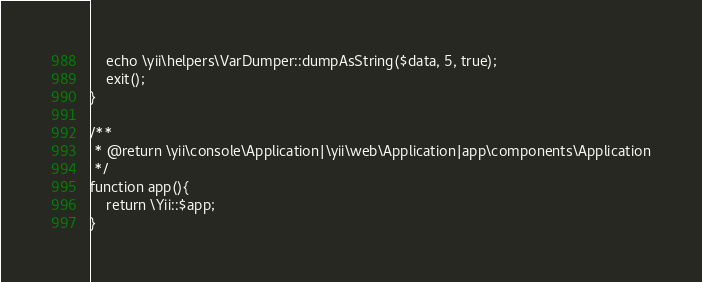Convert code to text. <code><loc_0><loc_0><loc_500><loc_500><_PHP_>    echo \yii\helpers\VarDumper::dumpAsString($data, 5, true);
    exit();
}

/**
 * @return \yii\console\Application|\yii\web\Application|app\components\Application
 */
function app(){
    return \Yii::$app;
}</code> 